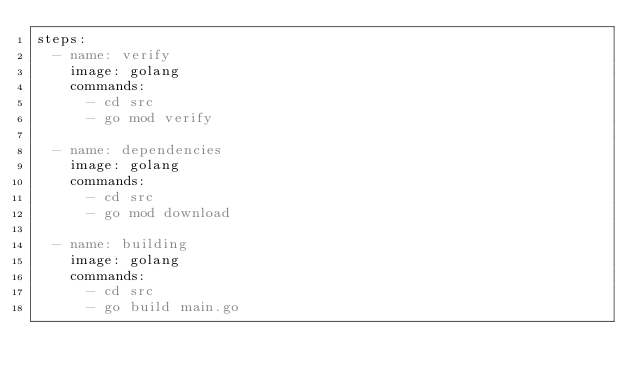<code> <loc_0><loc_0><loc_500><loc_500><_YAML_>steps:
  - name: verify
    image: golang
    commands:
      - cd src
      - go mod verify

  - name: dependencies
    image: golang
    commands:
      - cd src
      - go mod download

  - name: building
    image: golang
    commands:
      - cd src
      - go build main.go</code> 